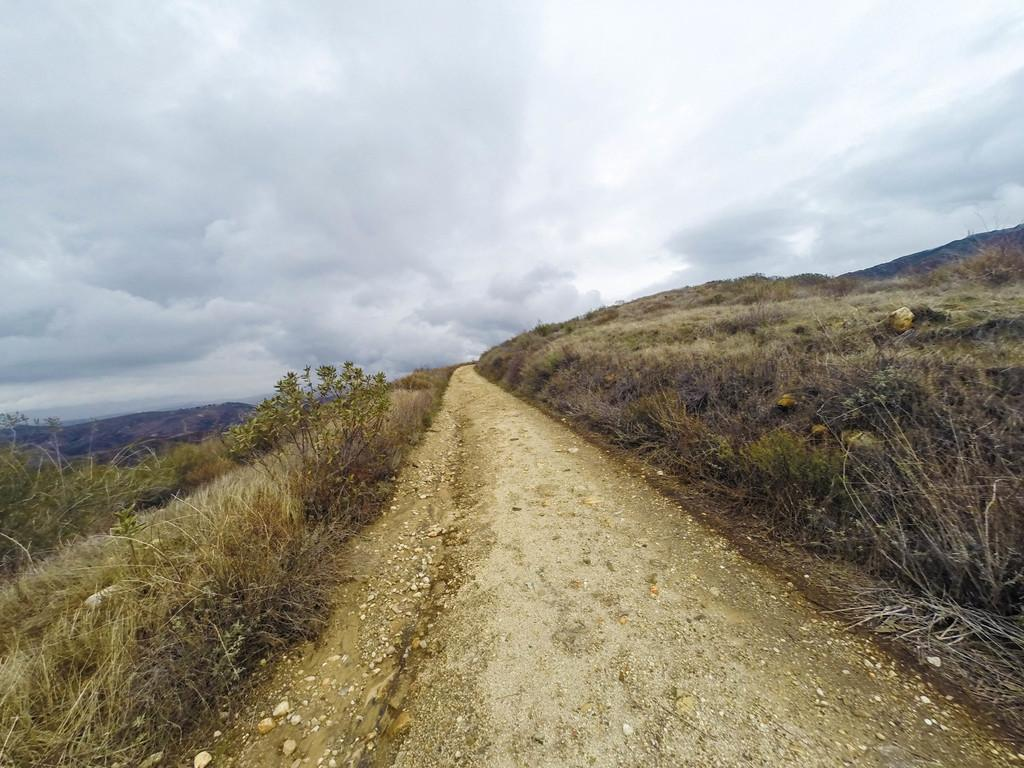What type of terrain is featured in the image? There is a road passage in the mountain in the image. What can be seen on both sides of the road? Dry grass and plants are present on both sides of the road. How would you describe the sky in the image? The sky is cloudy in the image. What size pencil can be seen in the image? There is no pencil present in the image. How many fifths are visible in the image? The concept of "fifths" does not apply to the image, as it features a road passage in the mountain, dry grass and plants, and a cloudy sky. 